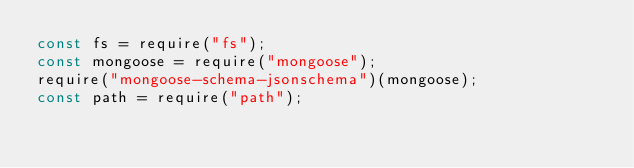Convert code to text. <code><loc_0><loc_0><loc_500><loc_500><_JavaScript_>const fs = require("fs");
const mongoose = require("mongoose");
require("mongoose-schema-jsonschema")(mongoose);
const path = require("path");
</code> 